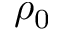Convert formula to latex. <formula><loc_0><loc_0><loc_500><loc_500>\rho _ { 0 }</formula> 